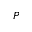<formula> <loc_0><loc_0><loc_500><loc_500>P</formula> 